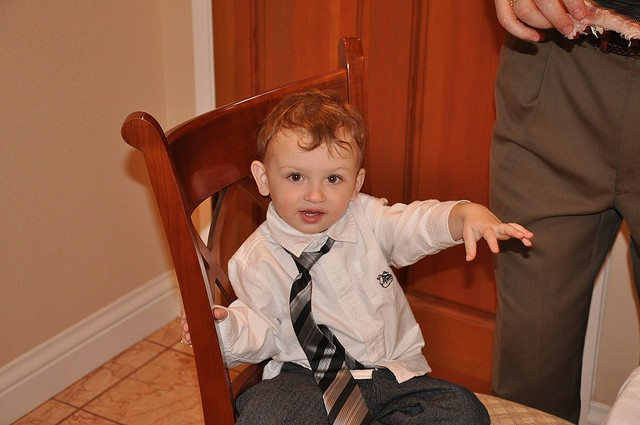Describe the objects in this image and their specific colors. I can see people in brown, maroon, black, and tan tones, chair in brown, maroon, and black tones, and tie in brown, black, and gray tones in this image. 